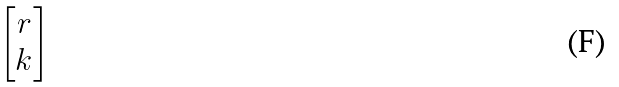Convert formula to latex. <formula><loc_0><loc_0><loc_500><loc_500>\begin{bmatrix} r \\ k \end{bmatrix}</formula> 